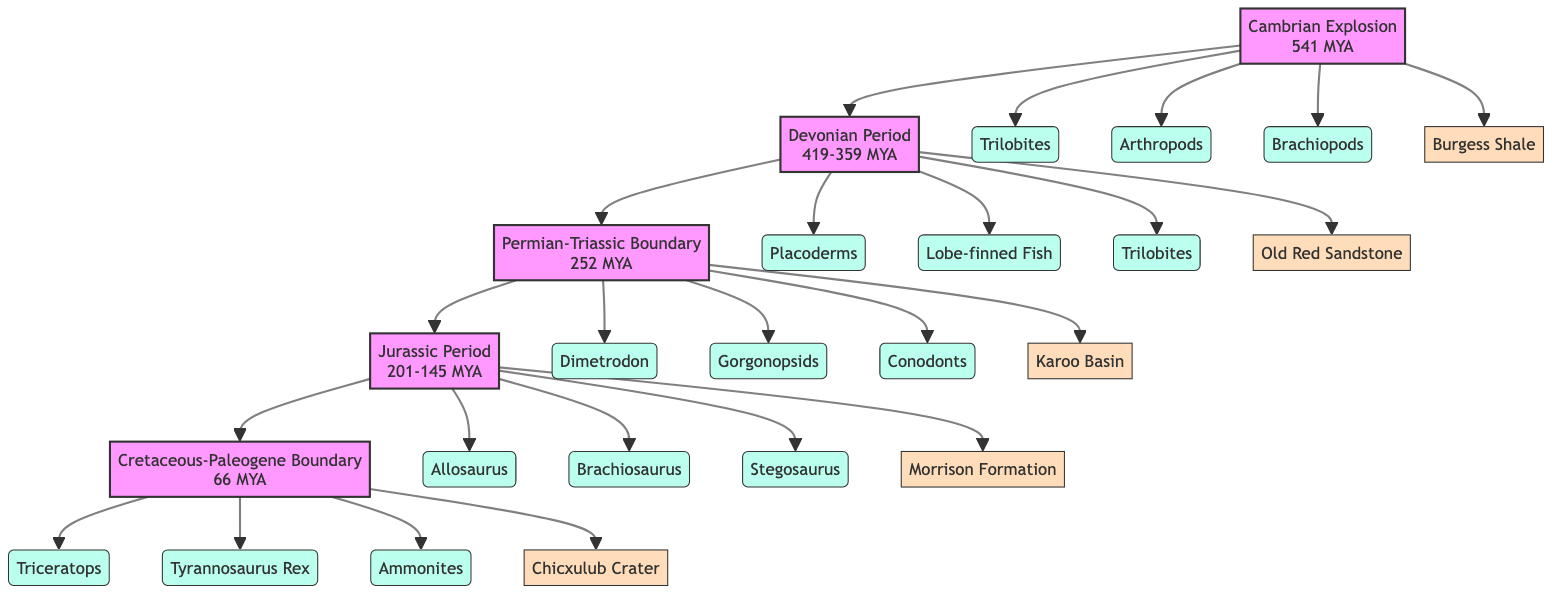What is the oldest formation represented in the diagram? The first layer in the diagram is the Cambrian Explosion, which is represented at the topmost position. This indicates that it is the oldest formation on the flowchart.
Answer: Cambrian Explosion How many key fossils are associated with the Jurassic Period? The Jurassic Period node shows three key fossils: Allosaurus, Brachiosaurus, and Stegosaurus. Counting these gives a total of three fossils.
Answer: 3 Which geological formation is linked to the Cretaceous-Paleogene Boundary? The diagram directly connects the Cretaceous-Paleogene Boundary with the Chicxulub Crater, illustrated right beneath that layer.
Answer: Chicxulub Crater List one key fossil from the Devonian Period. The Devonian Period node includes three key fossils, one of which is Placoderms, which can be identified readily from the node details.
Answer: Placoderms What event separates the Permian-Triassic Boundary from the Jurassic Period? The flowchart shows the Permian-Triassic Boundary leading directly into the Jurassic Period. Therefore, the event that separates them is simply the transition from the Permian-Triassic Boundary to the Jurassic Period.
Answer: Permian-Triassic Boundary How many fossils does the Cambrian Explosion feature? The Cambrian Explosion node lists three key fossils: Trilobites, Arthropods, and Brachiopods. Counting these gives a total of three fossils featured.
Answer: 3 Which geological formation is associated with the key fossils of Dimetrodon? The diagram links the key fossils of Dimetrodon to the Karoo Basin, as indicated beneath the Permian-Triassic Boundary node.
Answer: Karoo Basin Identify the period associated with the Ammonites fossil. By tracing the flowchart, Ammonites are listed as key fossils under the Cretaceous-Paleogene Boundary, thus linking them to that period.
Answer: Cretaceous-Paleogene Boundary What is the time span of the Jurassic Period? The diagram shows that the Jurassic Period extends from approximately 201 to 145 million years ago, specifically noted at the Jurassic Period node.
Answer: 201-145 MYA 